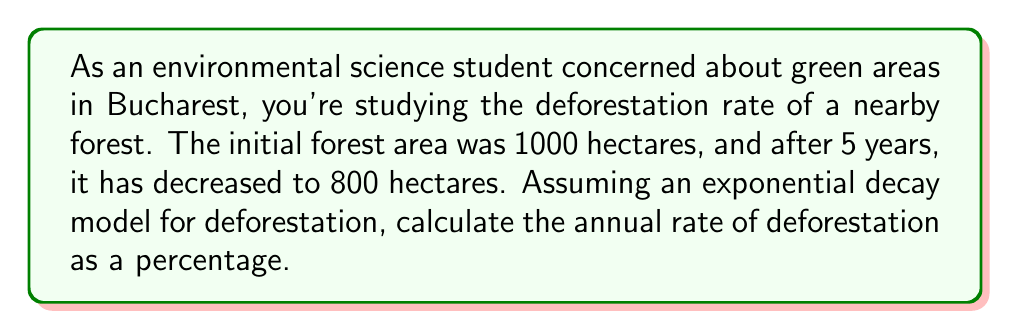Help me with this question. To solve this problem, we'll use the exponential decay model:

$$A(t) = A_0 e^{-rt}$$

Where:
$A(t)$ is the area at time $t$
$A_0$ is the initial area
$r$ is the decay rate (annual rate of deforestation)
$t$ is the time in years

We know:
$A_0 = 1000$ hectares
$A(5) = 800$ hectares
$t = 5$ years

Let's substitute these values into the equation:

$$800 = 1000 e^{-5r}$$

Now, let's solve for $r$:

1) Divide both sides by 1000:
   $$0.8 = e^{-5r}$$

2) Take the natural logarithm of both sides:
   $$\ln(0.8) = -5r$$

3) Solve for $r$:
   $$r = -\frac{\ln(0.8)}{5}$$

4) Calculate $r$:
   $$r \approx 0.0446$$

5) Convert to a percentage:
   $$r \approx 4.46\%$$

This means the forest is decreasing by approximately 4.46% per year.
Answer: The annual rate of deforestation is approximately 4.46%. 